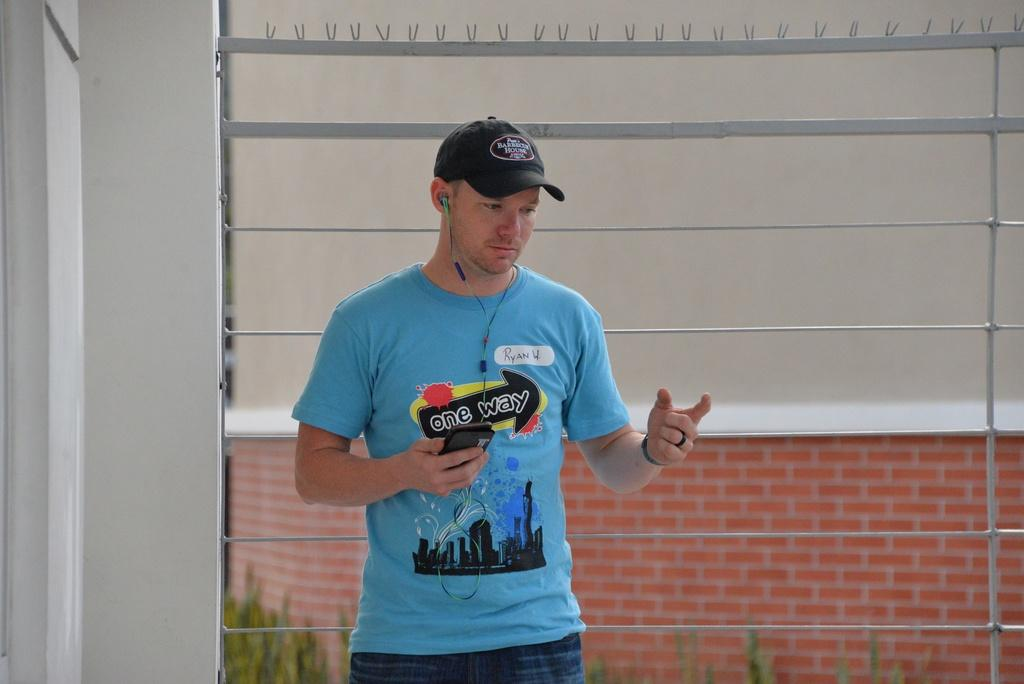What is the man in the image doing? The man is standing in the image. What is the man wearing on his head? The man is wearing a cap. What is the man wearing on his ears? The man is wearing a headset. What is the man holding in his hand? The man is holding a mobile. What can be seen in the background of the image? There is a wall and grass in the background of the image. What type of shirt is the man's son wearing in the image? There is no mention of a son in the image, and therefore no shirt can be described. 